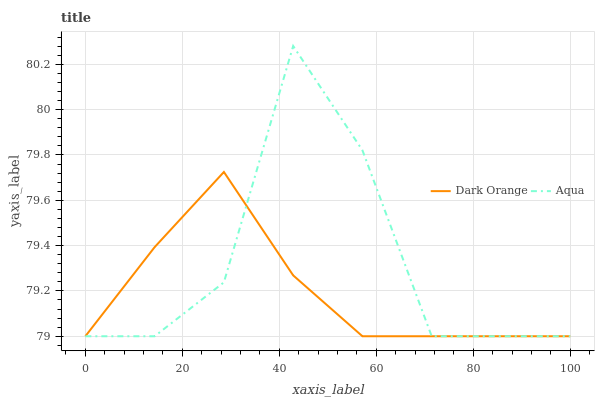Does Dark Orange have the minimum area under the curve?
Answer yes or no. Yes. Does Aqua have the maximum area under the curve?
Answer yes or no. Yes. Does Aqua have the minimum area under the curve?
Answer yes or no. No. Is Dark Orange the smoothest?
Answer yes or no. Yes. Is Aqua the roughest?
Answer yes or no. Yes. Is Aqua the smoothest?
Answer yes or no. No. Does Dark Orange have the lowest value?
Answer yes or no. Yes. Does Aqua have the highest value?
Answer yes or no. Yes. Does Aqua intersect Dark Orange?
Answer yes or no. Yes. Is Aqua less than Dark Orange?
Answer yes or no. No. Is Aqua greater than Dark Orange?
Answer yes or no. No. 